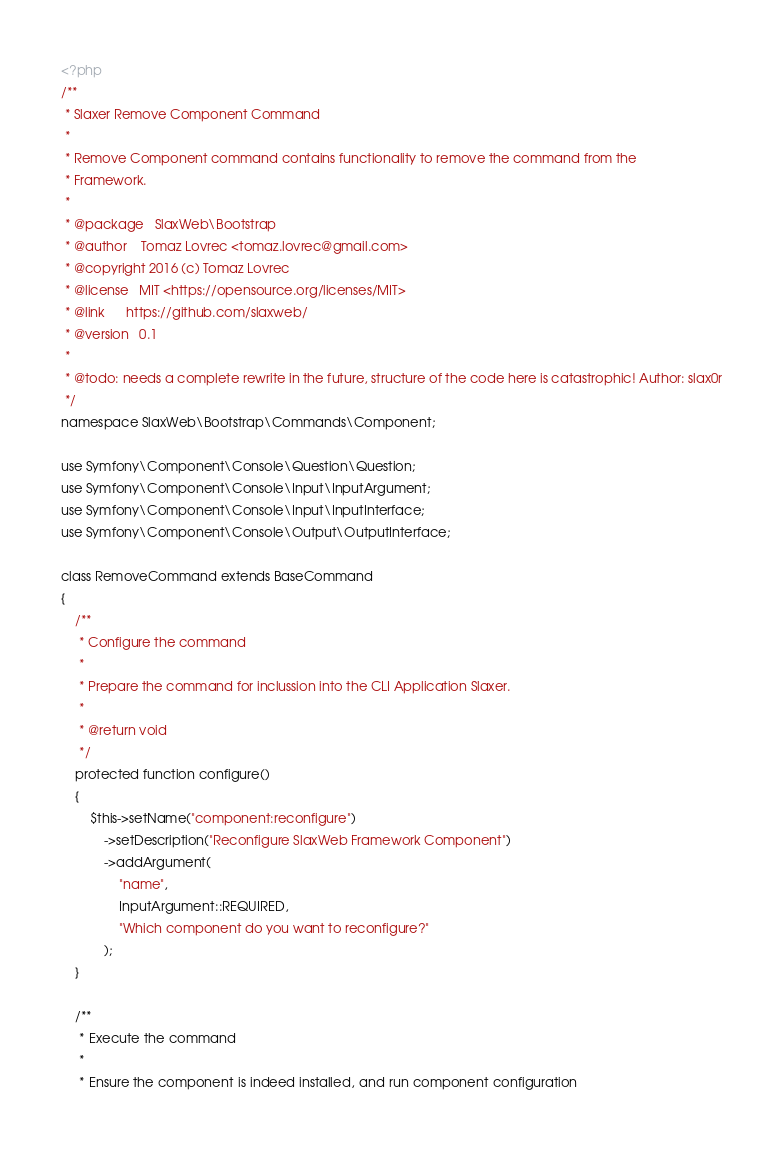<code> <loc_0><loc_0><loc_500><loc_500><_PHP_><?php
/**
 * Slaxer Remove Component Command
 *
 * Remove Component command contains functionality to remove the command from the
 * Framework.
 *
 * @package   SlaxWeb\Bootstrap
 * @author    Tomaz Lovrec <tomaz.lovrec@gmail.com>
 * @copyright 2016 (c) Tomaz Lovrec
 * @license   MIT <https://opensource.org/licenses/MIT>
 * @link      https://github.com/slaxweb/
 * @version   0.1
 *
 * @todo: needs a complete rewrite in the future, structure of the code here is catastrophic! Author: slax0r
 */
namespace SlaxWeb\Bootstrap\Commands\Component;

use Symfony\Component\Console\Question\Question;
use Symfony\Component\Console\Input\InputArgument;
use Symfony\Component\Console\Input\InputInterface;
use Symfony\Component\Console\Output\OutputInterface;

class RemoveCommand extends BaseCommand
{
    /**
     * Configure the command
     *
     * Prepare the command for inclussion into the CLI Application Slaxer.
     *
     * @return void
     */
    protected function configure()
    {
        $this->setName("component:reconfigure")
            ->setDescription("Reconfigure SlaxWeb Framework Component")
            ->addArgument(
                "name",
                InputArgument::REQUIRED,
                "Which component do you want to reconfigure?"
            );
    }

    /**
     * Execute the command
     *
     * Ensure the component is indeed installed, and run component configuration</code> 